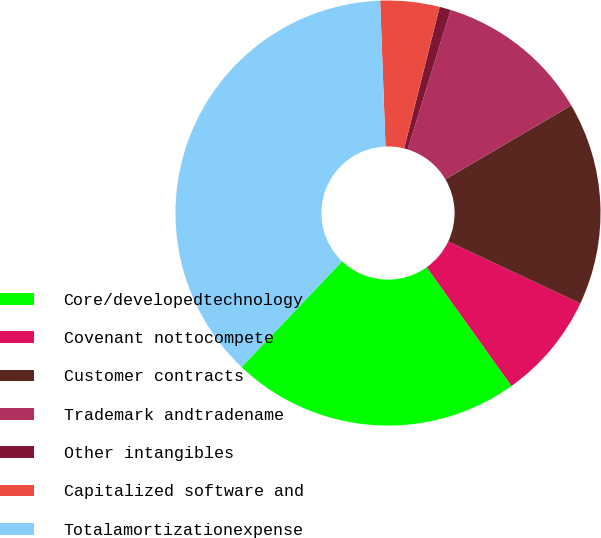<chart> <loc_0><loc_0><loc_500><loc_500><pie_chart><fcel>Core/developedtechnology<fcel>Covenant nottocompete<fcel>Customer contracts<fcel>Trademark andtradename<fcel>Other intangibles<fcel>Capitalized software and<fcel>Totalamortizationexpense<nl><fcel>21.97%<fcel>8.14%<fcel>15.44%<fcel>11.79%<fcel>0.85%<fcel>4.5%<fcel>37.31%<nl></chart> 